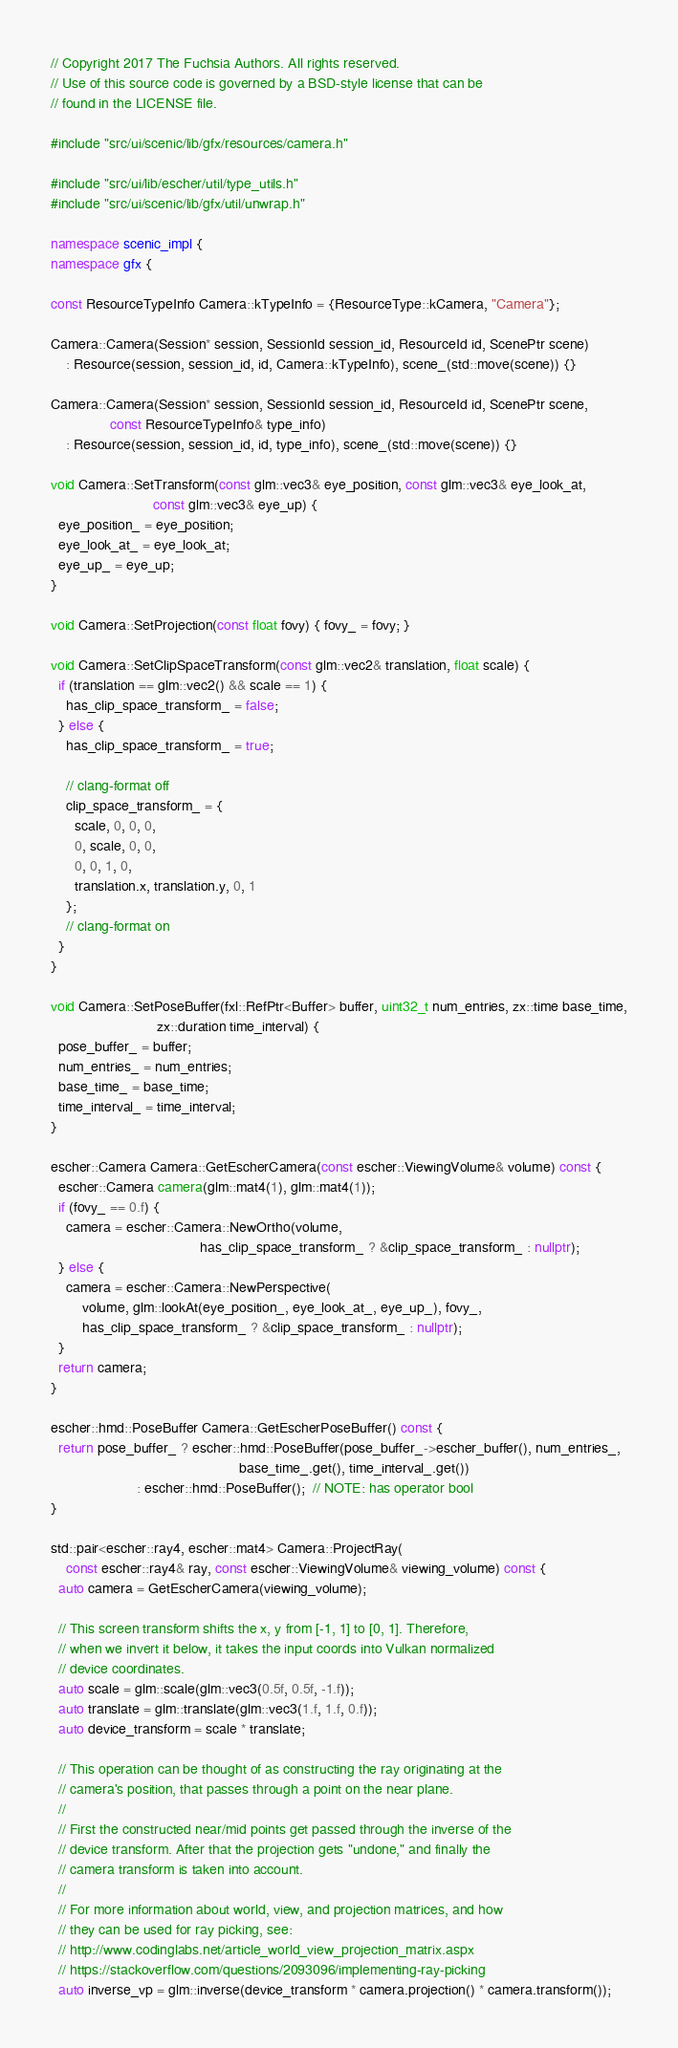Convert code to text. <code><loc_0><loc_0><loc_500><loc_500><_C++_>// Copyright 2017 The Fuchsia Authors. All rights reserved.
// Use of this source code is governed by a BSD-style license that can be
// found in the LICENSE file.

#include "src/ui/scenic/lib/gfx/resources/camera.h"

#include "src/ui/lib/escher/util/type_utils.h"
#include "src/ui/scenic/lib/gfx/util/unwrap.h"

namespace scenic_impl {
namespace gfx {

const ResourceTypeInfo Camera::kTypeInfo = {ResourceType::kCamera, "Camera"};

Camera::Camera(Session* session, SessionId session_id, ResourceId id, ScenePtr scene)
    : Resource(session, session_id, id, Camera::kTypeInfo), scene_(std::move(scene)) {}

Camera::Camera(Session* session, SessionId session_id, ResourceId id, ScenePtr scene,
               const ResourceTypeInfo& type_info)
    : Resource(session, session_id, id, type_info), scene_(std::move(scene)) {}

void Camera::SetTransform(const glm::vec3& eye_position, const glm::vec3& eye_look_at,
                          const glm::vec3& eye_up) {
  eye_position_ = eye_position;
  eye_look_at_ = eye_look_at;
  eye_up_ = eye_up;
}

void Camera::SetProjection(const float fovy) { fovy_ = fovy; }

void Camera::SetClipSpaceTransform(const glm::vec2& translation, float scale) {
  if (translation == glm::vec2() && scale == 1) {
    has_clip_space_transform_ = false;
  } else {
    has_clip_space_transform_ = true;

    // clang-format off
    clip_space_transform_ = {
      scale, 0, 0, 0,
      0, scale, 0, 0,
      0, 0, 1, 0,
      translation.x, translation.y, 0, 1
    };
    // clang-format on
  }
}

void Camera::SetPoseBuffer(fxl::RefPtr<Buffer> buffer, uint32_t num_entries, zx::time base_time,
                           zx::duration time_interval) {
  pose_buffer_ = buffer;
  num_entries_ = num_entries;
  base_time_ = base_time;
  time_interval_ = time_interval;
}

escher::Camera Camera::GetEscherCamera(const escher::ViewingVolume& volume) const {
  escher::Camera camera(glm::mat4(1), glm::mat4(1));
  if (fovy_ == 0.f) {
    camera = escher::Camera::NewOrtho(volume,
                                      has_clip_space_transform_ ? &clip_space_transform_ : nullptr);
  } else {
    camera = escher::Camera::NewPerspective(
        volume, glm::lookAt(eye_position_, eye_look_at_, eye_up_), fovy_,
        has_clip_space_transform_ ? &clip_space_transform_ : nullptr);
  }
  return camera;
}

escher::hmd::PoseBuffer Camera::GetEscherPoseBuffer() const {
  return pose_buffer_ ? escher::hmd::PoseBuffer(pose_buffer_->escher_buffer(), num_entries_,
                                                base_time_.get(), time_interval_.get())
                      : escher::hmd::PoseBuffer();  // NOTE: has operator bool
}

std::pair<escher::ray4, escher::mat4> Camera::ProjectRay(
    const escher::ray4& ray, const escher::ViewingVolume& viewing_volume) const {
  auto camera = GetEscherCamera(viewing_volume);

  // This screen transform shifts the x, y from [-1, 1] to [0, 1]. Therefore,
  // when we invert it below, it takes the input coords into Vulkan normalized
  // device coordinates.
  auto scale = glm::scale(glm::vec3(0.5f, 0.5f, -1.f));
  auto translate = glm::translate(glm::vec3(1.f, 1.f, 0.f));
  auto device_transform = scale * translate;

  // This operation can be thought of as constructing the ray originating at the
  // camera's position, that passes through a point on the near plane.
  //
  // First the constructed near/mid points get passed through the inverse of the
  // device transform. After that the projection gets "undone," and finally the
  // camera transform is taken into account.
  //
  // For more information about world, view, and projection matrices, and how
  // they can be used for ray picking, see:
  // http://www.codinglabs.net/article_world_view_projection_matrix.aspx
  // https://stackoverflow.com/questions/2093096/implementing-ray-picking
  auto inverse_vp = glm::inverse(device_transform * camera.projection() * camera.transform());
</code> 